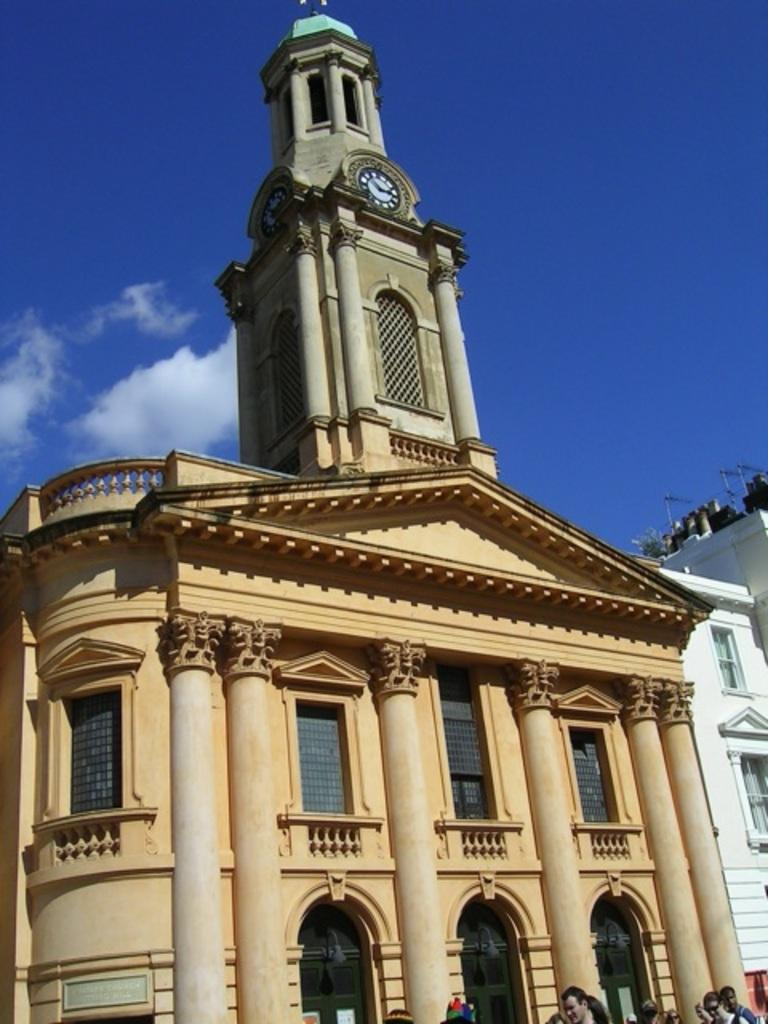What is located in the foreground of the image? There is a building, a crowd, and a tower in the foreground of the image. What can be seen in the background of the image? The sky is blue in the background of the image. When was the image taken? The image was taken during the day. What type of skirt is being worn by the tower in the image? There is no skirt present in the image, as the tower is an inanimate object. How many pancakes are visible on the building in the image? There are no pancakes present in the image; it features a building, a crowd, and a tower. 